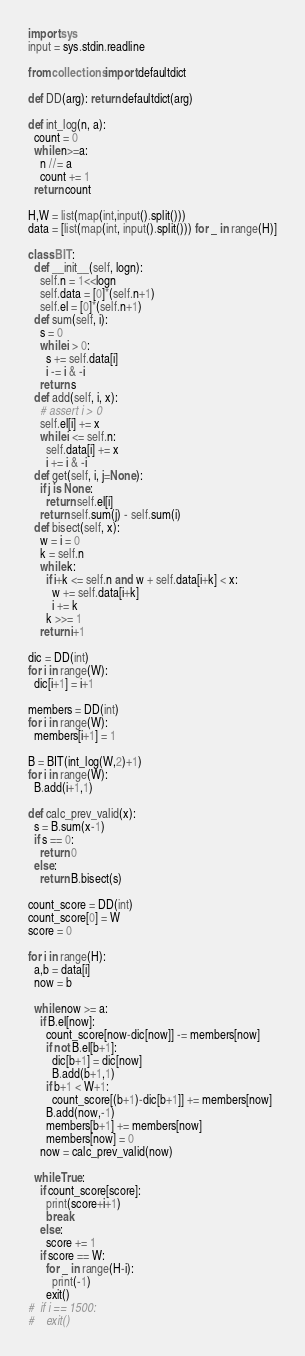<code> <loc_0><loc_0><loc_500><loc_500><_Python_>import sys
input = sys.stdin.readline

from collections import defaultdict

def DD(arg): return defaultdict(arg)

def int_log(n, a):
  count = 0
  while n>=a:
    n //= a
    count += 1
  return count

H,W = list(map(int,input().split()))
data = [list(map(int, input().split())) for _ in range(H)]

class BIT:
  def __init__(self, logn):
    self.n = 1<<logn
    self.data = [0]*(self.n+1)
    self.el = [0]*(self.n+1)
  def sum(self, i):
    s = 0
    while i > 0:
      s += self.data[i]
      i -= i & -i
    return s
  def add(self, i, x):
    # assert i > 0
    self.el[i] += x
    while i <= self.n:
      self.data[i] += x
      i += i & -i
  def get(self, i, j=None):
    if j is None:
      return self.el[i]
    return self.sum(j) - self.sum(i)
  def bisect(self, x):
    w = i = 0
    k = self.n
    while k:
      if i+k <= self.n and w + self.data[i+k] < x:
        w += self.data[i+k]
        i += k
      k >>= 1
    return i+1

dic = DD(int)
for i in range(W):
  dic[i+1] = i+1

members = DD(int)
for i in range(W):
  members[i+1] = 1

B = BIT(int_log(W,2)+1)
for i in range(W):
  B.add(i+1,1)

def calc_prev_valid(x):
  s = B.sum(x-1)
  if s == 0:
    return 0
  else:
    return B.bisect(s)

count_score = DD(int)
count_score[0] = W
score = 0

for i in range(H):
  a,b = data[i]
  now = b

  while now >= a:
    if B.el[now]:
      count_score[now-dic[now]] -= members[now]
      if not B.el[b+1]:
        dic[b+1] = dic[now]
        B.add(b+1,1)
      if b+1 < W+1:
        count_score[(b+1)-dic[b+1]] += members[now]
      B.add(now,-1)
      members[b+1] += members[now]
      members[now] = 0
    now = calc_prev_valid(now)

  while True:
    if count_score[score]:
      print(score+i+1)
      break
    else:
      score += 1
    if score == W:
      for _ in range(H-i):
        print(-1)
      exit()
#  if i == 1500:
#    exit()</code> 